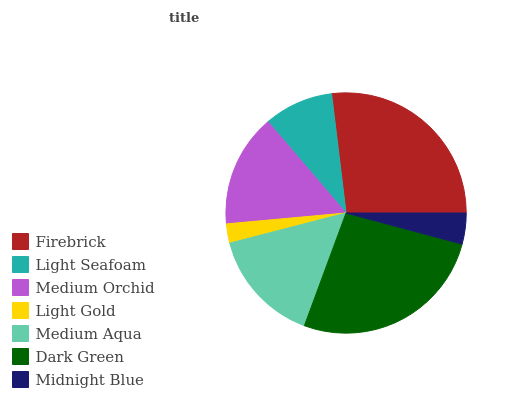Is Light Gold the minimum?
Answer yes or no. Yes. Is Firebrick the maximum?
Answer yes or no. Yes. Is Light Seafoam the minimum?
Answer yes or no. No. Is Light Seafoam the maximum?
Answer yes or no. No. Is Firebrick greater than Light Seafoam?
Answer yes or no. Yes. Is Light Seafoam less than Firebrick?
Answer yes or no. Yes. Is Light Seafoam greater than Firebrick?
Answer yes or no. No. Is Firebrick less than Light Seafoam?
Answer yes or no. No. Is Medium Orchid the high median?
Answer yes or no. Yes. Is Medium Orchid the low median?
Answer yes or no. Yes. Is Firebrick the high median?
Answer yes or no. No. Is Medium Aqua the low median?
Answer yes or no. No. 